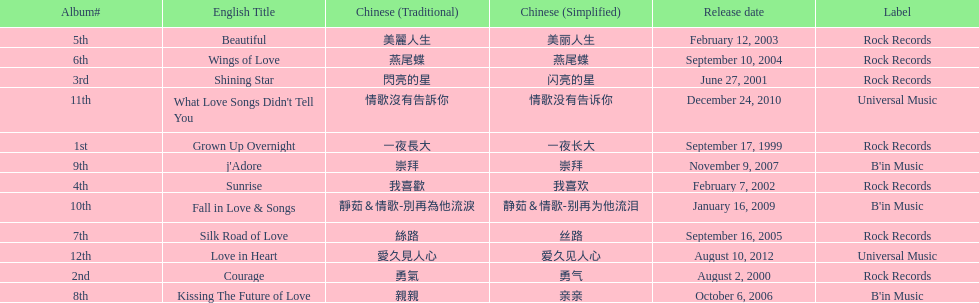What songs were on b'in music or universal music? Kissing The Future of Love, j'Adore, Fall in Love & Songs, What Love Songs Didn't Tell You, Love in Heart. 